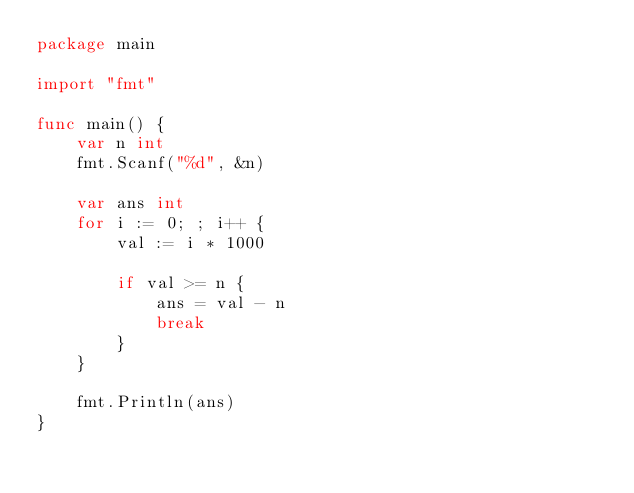<code> <loc_0><loc_0><loc_500><loc_500><_Go_>package main

import "fmt"

func main() {
	var n int
	fmt.Scanf("%d", &n)

	var ans int
	for i := 0; ; i++ {
		val := i * 1000

		if val >= n {
			ans = val - n
			break
		}
	}

	fmt.Println(ans)
}</code> 